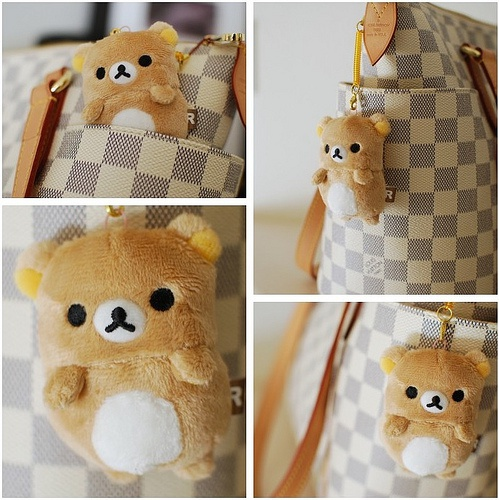Describe the objects in this image and their specific colors. I can see handbag in white, gray, tan, and maroon tones, teddy bear in white, tan, olive, and lightgray tones, handbag in white, lightgray, tan, brown, and darkgray tones, handbag in white, darkgray, tan, lightgray, and gray tones, and teddy bear in white, olive, tan, and lightgray tones in this image. 